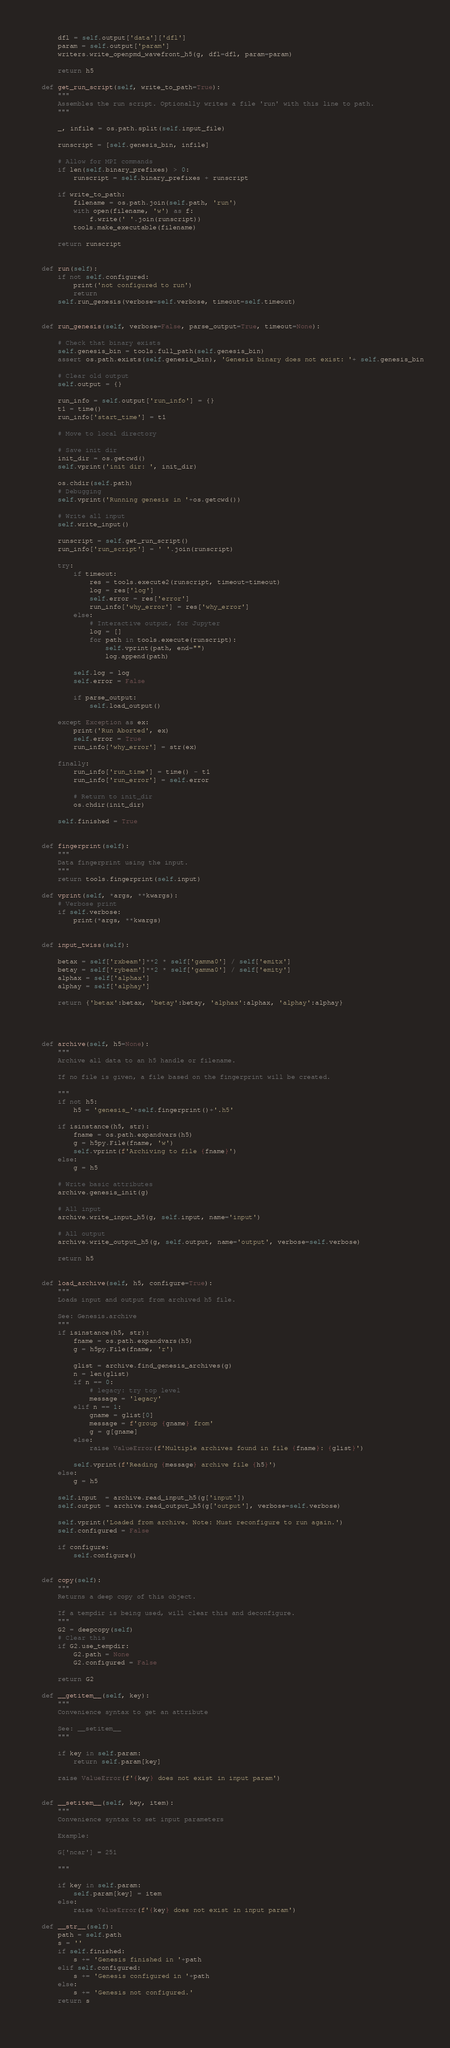Convert code to text. <code><loc_0><loc_0><loc_500><loc_500><_Python_>        
        dfl = self.output['data']['dfl']
        param = self.output['param']
        writers.write_openpmd_wavefront_h5(g, dfl=dfl, param=param)        
        
        return h5
            
    def get_run_script(self, write_to_path=True):
        """
        Assembles the run script. Optionally writes a file 'run' with this line to path.
        """
        
        _, infile = os.path.split(self.input_file)
        
        runscript = [self.genesis_bin, infile]

        # Allow for MPI commands
        if len(self.binary_prefixes) > 0:
            runscript = self.binary_prefixes + runscript
            
        if write_to_path:
            filename = os.path.join(self.path, 'run')
            with open(filename, 'w') as f:
                f.write(' '.join(runscript))
            tools.make_executable(filename)
            
        return runscript
        
            
    def run(self):
        if not self.configured:
            print('not configured to run')
            return
        self.run_genesis(verbose=self.verbose, timeout=self.timeout)    

        
    def run_genesis(self, verbose=False, parse_output=True, timeout=None):
        
        # Check that binary exists
        self.genesis_bin = tools.full_path(self.genesis_bin)
        assert os.path.exists(self.genesis_bin), 'Genesis binary does not exist: '+ self.genesis_bin
        
        # Clear old output
        self.output = {}
        
        run_info = self.output['run_info'] = {}
        t1 = time()
        run_info['start_time'] = t1

        # Move to local directory

        # Save init dir
        init_dir = os.getcwd()
        self.vprint('init dir: ', init_dir)
        
        os.chdir(self.path)
        # Debugging
        self.vprint('Running genesis in '+os.getcwd())

        # Write all input
        self.write_input()
        
        runscript = self.get_run_script()
        run_info['run_script'] = ' '.join(runscript)
        
        try:
            if timeout:
                res = tools.execute2(runscript, timeout=timeout)
                log = res['log']
                self.error = res['error']
                run_info['why_error'] = res['why_error']    
            else:
                # Interactive output, for Jupyter
                log = []
                for path in tools.execute(runscript):
                    self.vprint(path, end="")
                    log.append(path)
    
            self.log = log
            self.error = False   

            if parse_output:
                self.load_output()
                
        except Exception as ex:
            print('Run Aborted', ex)
            self.error = True
            run_info['why_error'] = str(ex)
            
        finally:
            run_info['run_time'] = time() - t1
            run_info['run_error'] = self.error
            
            # Return to init_dir
            os.chdir(init_dir)                        
        
        self.finished = True        

        
    def fingerprint(self):
        """
        Data fingerprint using the input. 
        """
        return tools.fingerprint(self.input)        
    
    def vprint(self, *args, **kwargs):
        # Verbose print
        if self.verbose:
            print(*args, **kwargs)   
           
        
    def input_twiss(self):
        
        betax = self['rxbeam']**2 * self['gamma0'] / self['emitx']
        betay = self['rybeam']**2 * self['gamma0'] / self['emity']
        alphax = self['alphax']
        alphay = self['alphay']
        
        return {'betax':betax, 'betay':betay, 'alphax':alphax, 'alphay':alphay}   
    
    
    
    
    def archive(self, h5=None):
        """
        Archive all data to an h5 handle or filename.
        
        If no file is given, a file based on the fingerprint will be created.
        
        """
        if not h5:
            h5 = 'genesis_'+self.fingerprint()+'.h5'
         
        if isinstance(h5, str):
            fname = os.path.expandvars(h5)
            g = h5py.File(fname, 'w')
            self.vprint(f'Archiving to file {fname}')
        else:
            g = h5
            
        # Write basic attributes
        archive.genesis_init(g)            
                        
        # All input
        archive.write_input_h5(g, self.input, name='input')

        # All output
        archive.write_output_h5(g, self.output, name='output', verbose=self.verbose) 
        
        return h5

    
    def load_archive(self, h5, configure=True):
        """
        Loads input and output from archived h5 file.
        
        See: Genesis.archive
        """
        if isinstance(h5, str):
            fname = os.path.expandvars(h5)
            g = h5py.File(fname, 'r')
            
            glist = archive.find_genesis_archives(g)
            n = len(glist)
            if n == 0:
                # legacy: try top level
                message = 'legacy'
            elif n == 1:
                gname = glist[0]
                message = f'group {gname} from'
                g = g[gname]
            else:
                raise ValueError(f'Multiple archives found in file {fname}: {glist}')
            
            self.vprint(f'Reading {message} archive file {h5}')
        else:
            g = h5
        
        self.input  = archive.read_input_h5(g['input'])
        self.output = archive.read_output_h5(g['output'], verbose=self.verbose)

        self.vprint('Loaded from archive. Note: Must reconfigure to run again.')
        self.configured = False     
        
        if configure:    
            self.configure()          
    
    
    def copy(self):
        """
        Returns a deep copy of this object.
        
        If a tempdir is being used, will clear this and deconfigure. 
        """
        G2 = deepcopy(self)
        # Clear this 
        if G2.use_tempdir:
            G2.path = None
            G2.configured = False
        
        return G2
    
    def __getitem__(self, key):
        """
        Convenience syntax to get an attribute
        
        See: __setitem__
        """        
        
        if key in self.param:
            return self.param[key]
        
        raise ValueError(f'{key} does not exist in input param')
        
        
    def __setitem__(self, key, item):
        """
        Convenience syntax to set input parameters
        
        Example:
        
        G['ncar'] = 251
        
        """
        
        if key in self.param:
            self.param[key] = item
        else:   
            raise ValueError(f'{key} does not exist in input param')
    
    def __str__(self):
        path = self.path
        s = ''
        if self.finished:
            s += 'Genesis finished in '+path
        elif self.configured:
            s += 'Genesis configured in '+path
        else:
            s += 'Genesis not configured.'
        return s    
    
    
</code> 